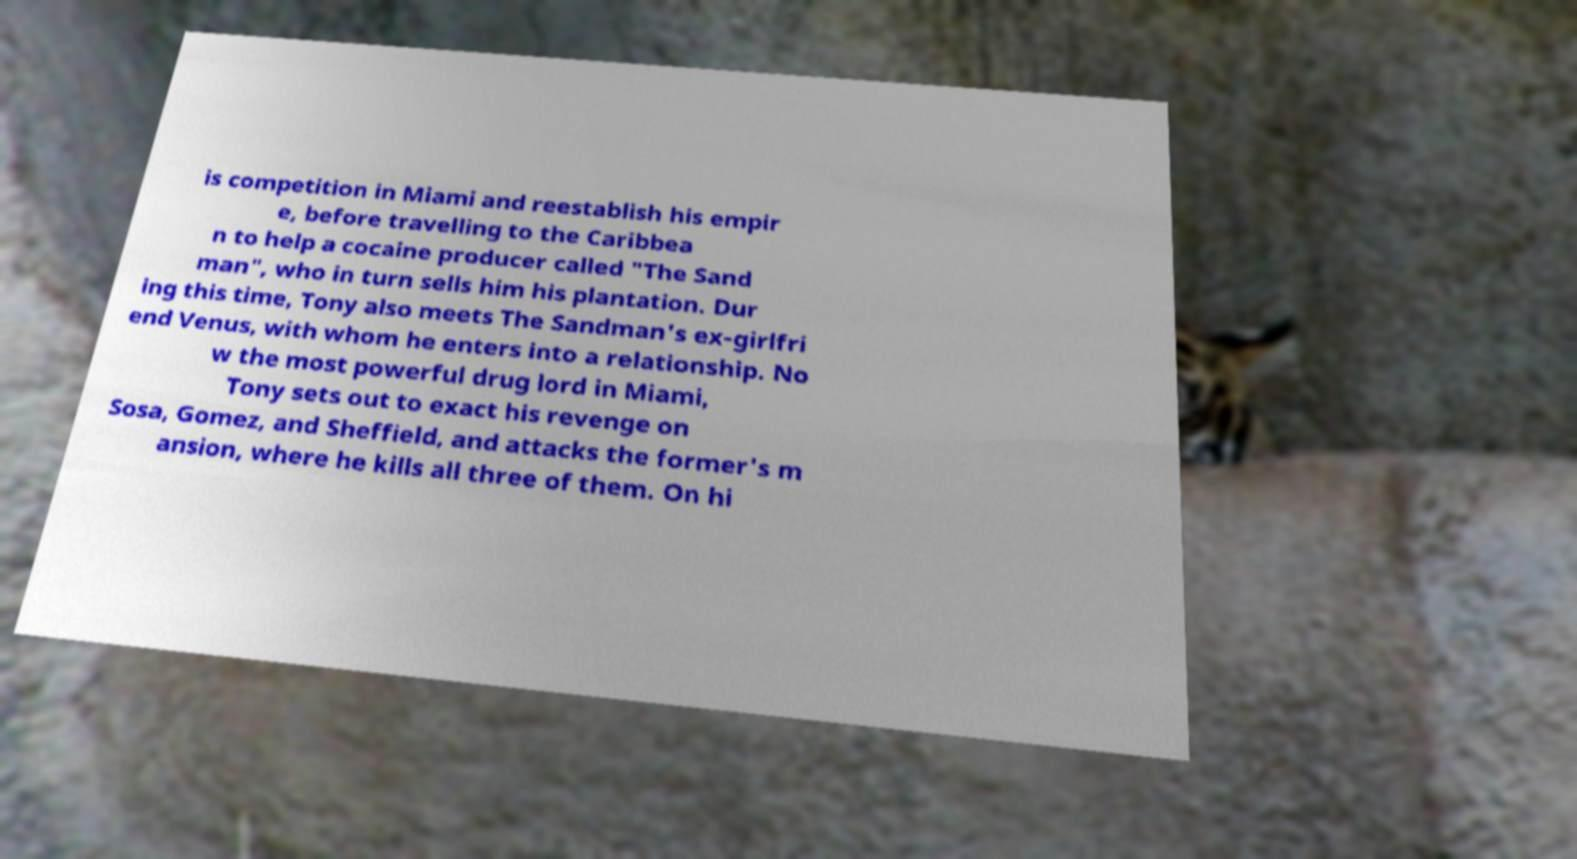Could you extract and type out the text from this image? is competition in Miami and reestablish his empir e, before travelling to the Caribbea n to help a cocaine producer called "The Sand man", who in turn sells him his plantation. Dur ing this time, Tony also meets The Sandman's ex-girlfri end Venus, with whom he enters into a relationship. No w the most powerful drug lord in Miami, Tony sets out to exact his revenge on Sosa, Gomez, and Sheffield, and attacks the former's m ansion, where he kills all three of them. On hi 